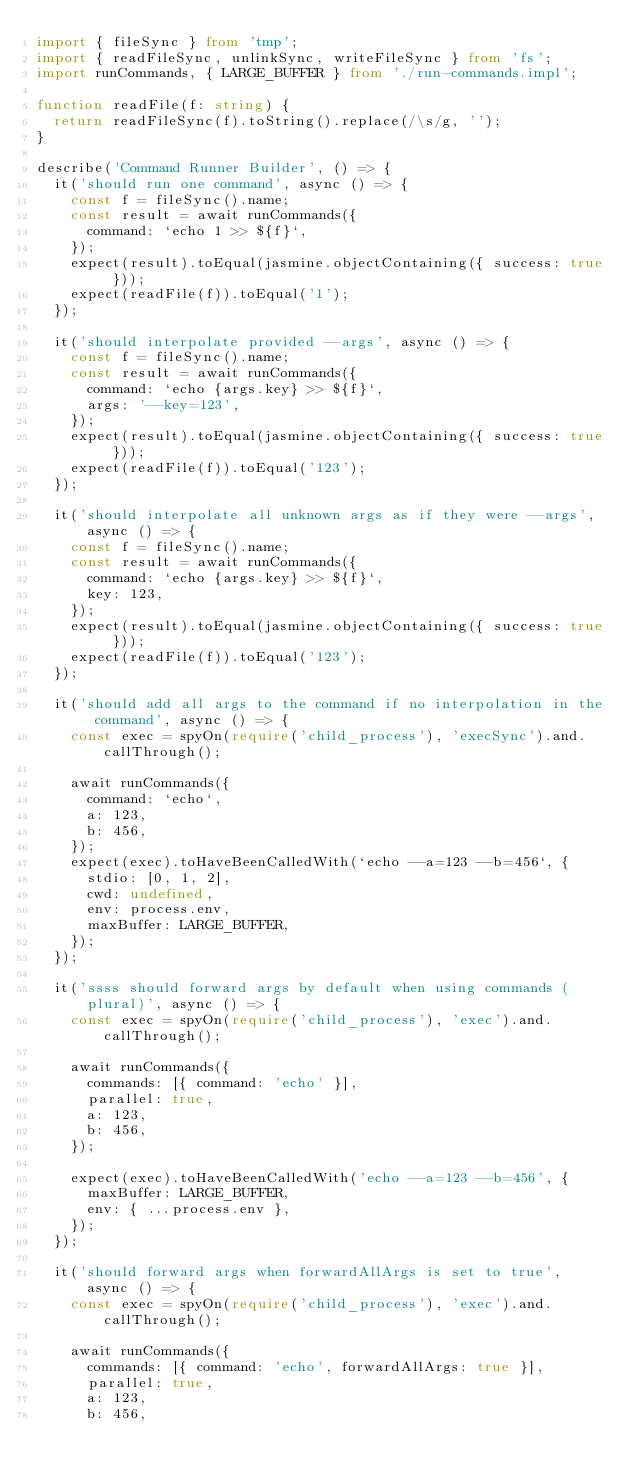Convert code to text. <code><loc_0><loc_0><loc_500><loc_500><_TypeScript_>import { fileSync } from 'tmp';
import { readFileSync, unlinkSync, writeFileSync } from 'fs';
import runCommands, { LARGE_BUFFER } from './run-commands.impl';

function readFile(f: string) {
  return readFileSync(f).toString().replace(/\s/g, '');
}

describe('Command Runner Builder', () => {
  it('should run one command', async () => {
    const f = fileSync().name;
    const result = await runCommands({
      command: `echo 1 >> ${f}`,
    });
    expect(result).toEqual(jasmine.objectContaining({ success: true }));
    expect(readFile(f)).toEqual('1');
  });

  it('should interpolate provided --args', async () => {
    const f = fileSync().name;
    const result = await runCommands({
      command: `echo {args.key} >> ${f}`,
      args: '--key=123',
    });
    expect(result).toEqual(jasmine.objectContaining({ success: true }));
    expect(readFile(f)).toEqual('123');
  });

  it('should interpolate all unknown args as if they were --args', async () => {
    const f = fileSync().name;
    const result = await runCommands({
      command: `echo {args.key} >> ${f}`,
      key: 123,
    });
    expect(result).toEqual(jasmine.objectContaining({ success: true }));
    expect(readFile(f)).toEqual('123');
  });

  it('should add all args to the command if no interpolation in the command', async () => {
    const exec = spyOn(require('child_process'), 'execSync').and.callThrough();

    await runCommands({
      command: `echo`,
      a: 123,
      b: 456,
    });
    expect(exec).toHaveBeenCalledWith(`echo --a=123 --b=456`, {
      stdio: [0, 1, 2],
      cwd: undefined,
      env: process.env,
      maxBuffer: LARGE_BUFFER,
    });
  });

  it('ssss should forward args by default when using commands (plural)', async () => {
    const exec = spyOn(require('child_process'), 'exec').and.callThrough();

    await runCommands({
      commands: [{ command: 'echo' }],
      parallel: true,
      a: 123,
      b: 456,
    });

    expect(exec).toHaveBeenCalledWith('echo --a=123 --b=456', {
      maxBuffer: LARGE_BUFFER,
      env: { ...process.env },
    });
  });

  it('should forward args when forwardAllArgs is set to true', async () => {
    const exec = spyOn(require('child_process'), 'exec').and.callThrough();

    await runCommands({
      commands: [{ command: 'echo', forwardAllArgs: true }],
      parallel: true,
      a: 123,
      b: 456,</code> 